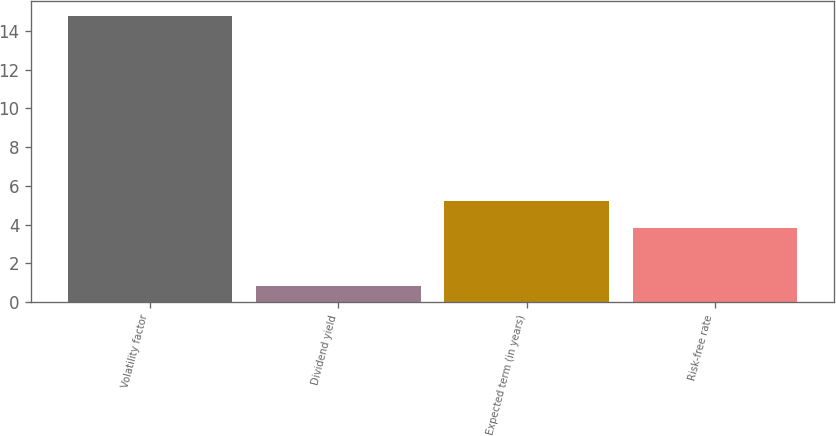Convert chart to OTSL. <chart><loc_0><loc_0><loc_500><loc_500><bar_chart><fcel>Volatility factor<fcel>Dividend yield<fcel>Expected term (in years)<fcel>Risk-free rate<nl><fcel>14.8<fcel>0.8<fcel>5.2<fcel>3.8<nl></chart> 